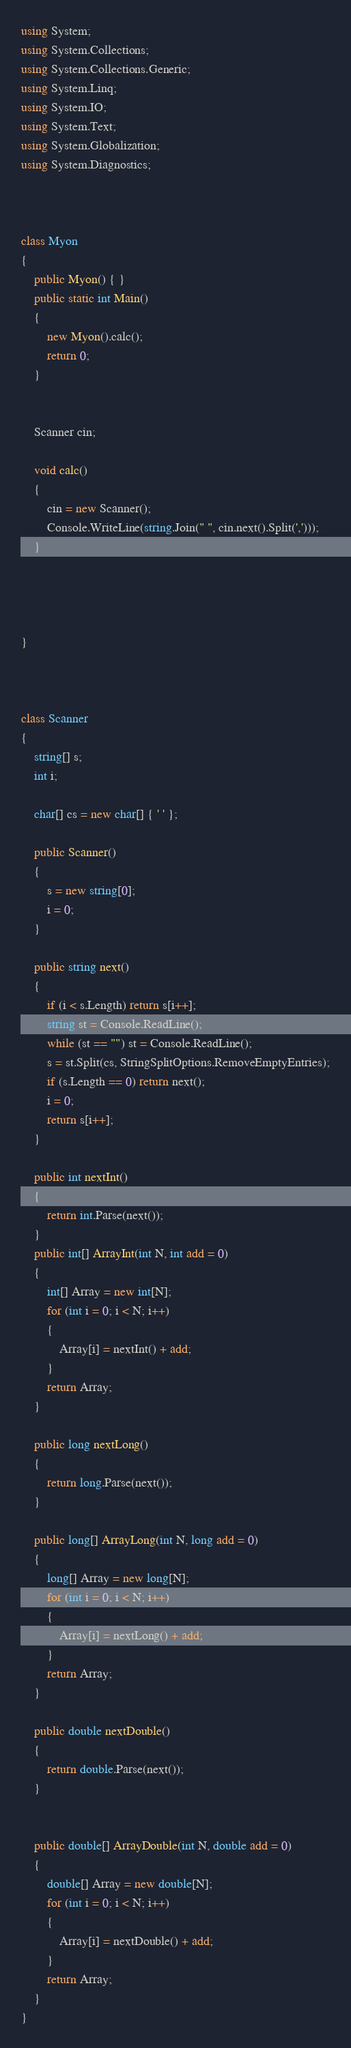<code> <loc_0><loc_0><loc_500><loc_500><_C#_>using System;
using System.Collections;
using System.Collections.Generic;
using System.Linq;
using System.IO;
using System.Text;
using System.Globalization;
using System.Diagnostics;



class Myon
{
    public Myon() { }
    public static int Main()
    {
        new Myon().calc();
        return 0;
    }
    

    Scanner cin;

    void calc()
    {
        cin = new Scanner();
        Console.WriteLine(string.Join(" ", cin.next().Split(',')));
    }




}



class Scanner
{
    string[] s;
    int i;

    char[] cs = new char[] { ' ' };

    public Scanner()
    {
        s = new string[0];
        i = 0;
    }

    public string next()
    {
        if (i < s.Length) return s[i++];
        string st = Console.ReadLine();
        while (st == "") st = Console.ReadLine();
        s = st.Split(cs, StringSplitOptions.RemoveEmptyEntries);
        if (s.Length == 0) return next();
        i = 0;
        return s[i++];
    }

    public int nextInt()
    {
        return int.Parse(next());
    }
    public int[] ArrayInt(int N, int add = 0)
    {
        int[] Array = new int[N];
        for (int i = 0; i < N; i++)
        {
            Array[i] = nextInt() + add;
        }
        return Array;
    }

    public long nextLong()
    {
        return long.Parse(next());
    }

    public long[] ArrayLong(int N, long add = 0)
    {
        long[] Array = new long[N];
        for (int i = 0; i < N; i++)
        {
            Array[i] = nextLong() + add;
        }
        return Array;
    }

    public double nextDouble()
    {
        return double.Parse(next());
    }


    public double[] ArrayDouble(int N, double add = 0)
    {
        double[] Array = new double[N];
        for (int i = 0; i < N; i++)
        {
            Array[i] = nextDouble() + add;
        }
        return Array;
    }
}</code> 